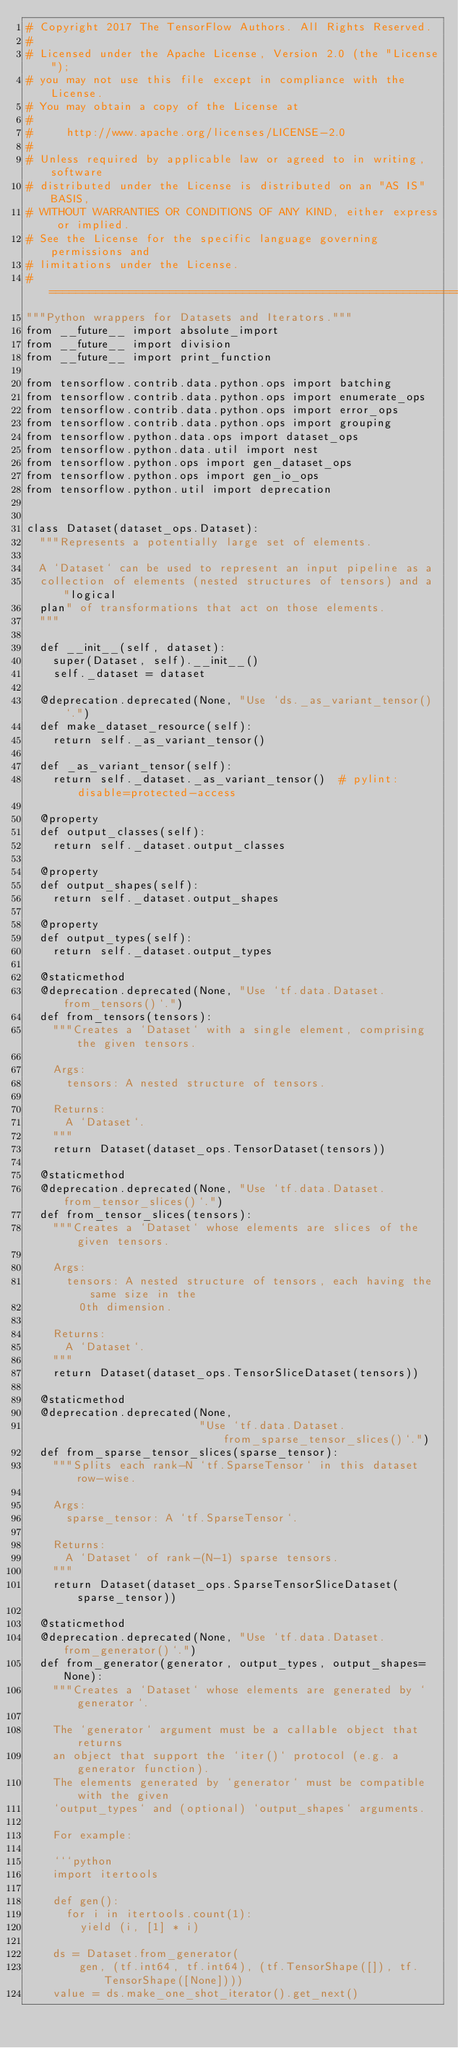<code> <loc_0><loc_0><loc_500><loc_500><_Python_># Copyright 2017 The TensorFlow Authors. All Rights Reserved.
#
# Licensed under the Apache License, Version 2.0 (the "License");
# you may not use this file except in compliance with the License.
# You may obtain a copy of the License at
#
#     http://www.apache.org/licenses/LICENSE-2.0
#
# Unless required by applicable law or agreed to in writing, software
# distributed under the License is distributed on an "AS IS" BASIS,
# WITHOUT WARRANTIES OR CONDITIONS OF ANY KIND, either express or implied.
# See the License for the specific language governing permissions and
# limitations under the License.
# ==============================================================================
"""Python wrappers for Datasets and Iterators."""
from __future__ import absolute_import
from __future__ import division
from __future__ import print_function

from tensorflow.contrib.data.python.ops import batching
from tensorflow.contrib.data.python.ops import enumerate_ops
from tensorflow.contrib.data.python.ops import error_ops
from tensorflow.contrib.data.python.ops import grouping
from tensorflow.python.data.ops import dataset_ops
from tensorflow.python.data.util import nest
from tensorflow.python.ops import gen_dataset_ops
from tensorflow.python.ops import gen_io_ops
from tensorflow.python.util import deprecation


class Dataset(dataset_ops.Dataset):
  """Represents a potentially large set of elements.

  A `Dataset` can be used to represent an input pipeline as a
  collection of elements (nested structures of tensors) and a "logical
  plan" of transformations that act on those elements.
  """

  def __init__(self, dataset):
    super(Dataset, self).__init__()
    self._dataset = dataset

  @deprecation.deprecated(None, "Use `ds._as_variant_tensor()`.")
  def make_dataset_resource(self):
    return self._as_variant_tensor()

  def _as_variant_tensor(self):
    return self._dataset._as_variant_tensor()  # pylint: disable=protected-access

  @property
  def output_classes(self):
    return self._dataset.output_classes

  @property
  def output_shapes(self):
    return self._dataset.output_shapes

  @property
  def output_types(self):
    return self._dataset.output_types

  @staticmethod
  @deprecation.deprecated(None, "Use `tf.data.Dataset.from_tensors()`.")
  def from_tensors(tensors):
    """Creates a `Dataset` with a single element, comprising the given tensors.

    Args:
      tensors: A nested structure of tensors.

    Returns:
      A `Dataset`.
    """
    return Dataset(dataset_ops.TensorDataset(tensors))

  @staticmethod
  @deprecation.deprecated(None, "Use `tf.data.Dataset.from_tensor_slices()`.")
  def from_tensor_slices(tensors):
    """Creates a `Dataset` whose elements are slices of the given tensors.

    Args:
      tensors: A nested structure of tensors, each having the same size in the
        0th dimension.

    Returns:
      A `Dataset`.
    """
    return Dataset(dataset_ops.TensorSliceDataset(tensors))

  @staticmethod
  @deprecation.deprecated(None,
                          "Use `tf.data.Dataset.from_sparse_tensor_slices()`.")
  def from_sparse_tensor_slices(sparse_tensor):
    """Splits each rank-N `tf.SparseTensor` in this dataset row-wise.

    Args:
      sparse_tensor: A `tf.SparseTensor`.

    Returns:
      A `Dataset` of rank-(N-1) sparse tensors.
    """
    return Dataset(dataset_ops.SparseTensorSliceDataset(sparse_tensor))

  @staticmethod
  @deprecation.deprecated(None, "Use `tf.data.Dataset.from_generator()`.")
  def from_generator(generator, output_types, output_shapes=None):
    """Creates a `Dataset` whose elements are generated by `generator`.

    The `generator` argument must be a callable object that returns
    an object that support the `iter()` protocol (e.g. a generator function).
    The elements generated by `generator` must be compatible with the given
    `output_types` and (optional) `output_shapes` arguments.

    For example:

    ```python
    import itertools

    def gen():
      for i in itertools.count(1):
        yield (i, [1] * i)

    ds = Dataset.from_generator(
        gen, (tf.int64, tf.int64), (tf.TensorShape([]), tf.TensorShape([None])))
    value = ds.make_one_shot_iterator().get_next()
</code> 